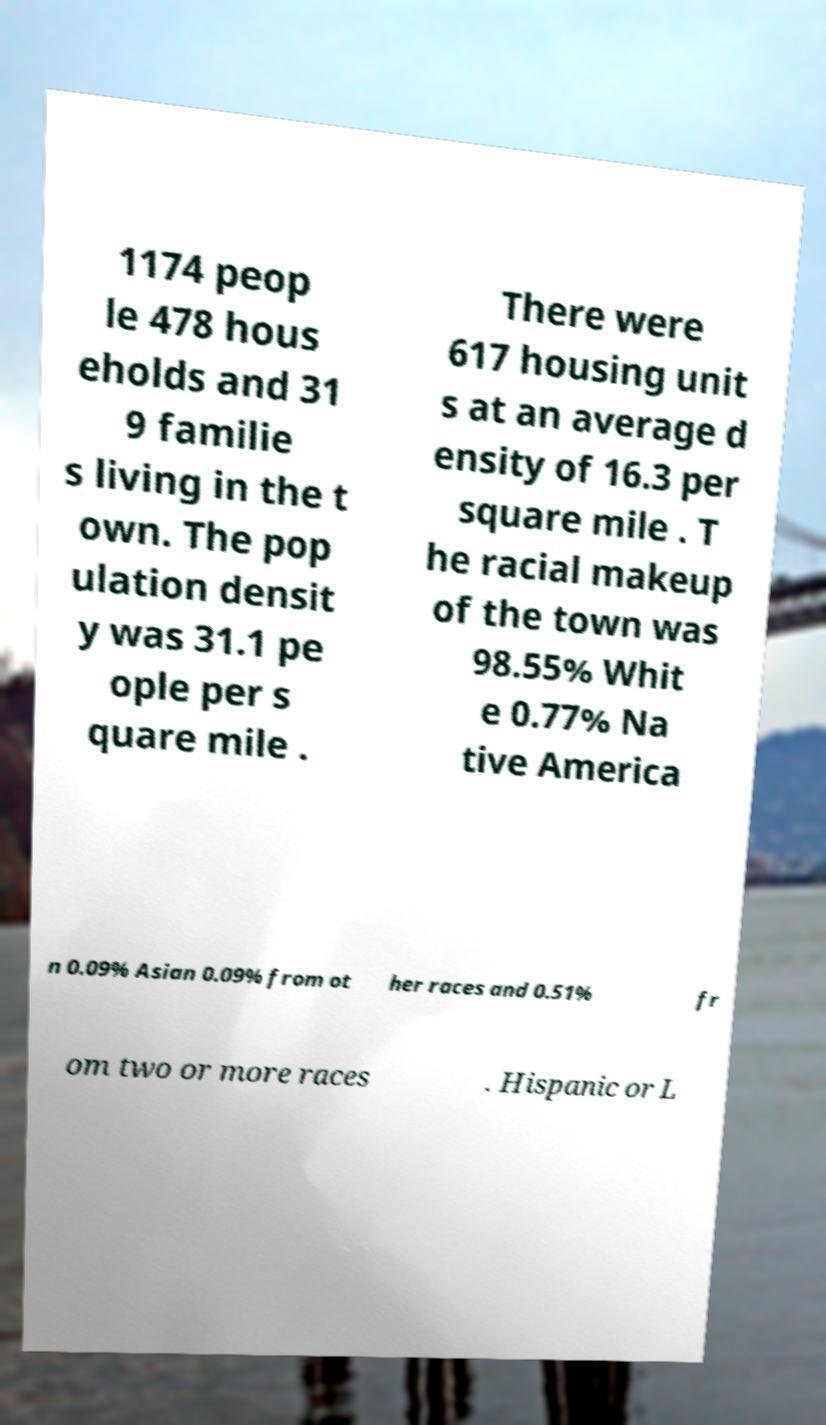Could you assist in decoding the text presented in this image and type it out clearly? 1174 peop le 478 hous eholds and 31 9 familie s living in the t own. The pop ulation densit y was 31.1 pe ople per s quare mile . There were 617 housing unit s at an average d ensity of 16.3 per square mile . T he racial makeup of the town was 98.55% Whit e 0.77% Na tive America n 0.09% Asian 0.09% from ot her races and 0.51% fr om two or more races . Hispanic or L 